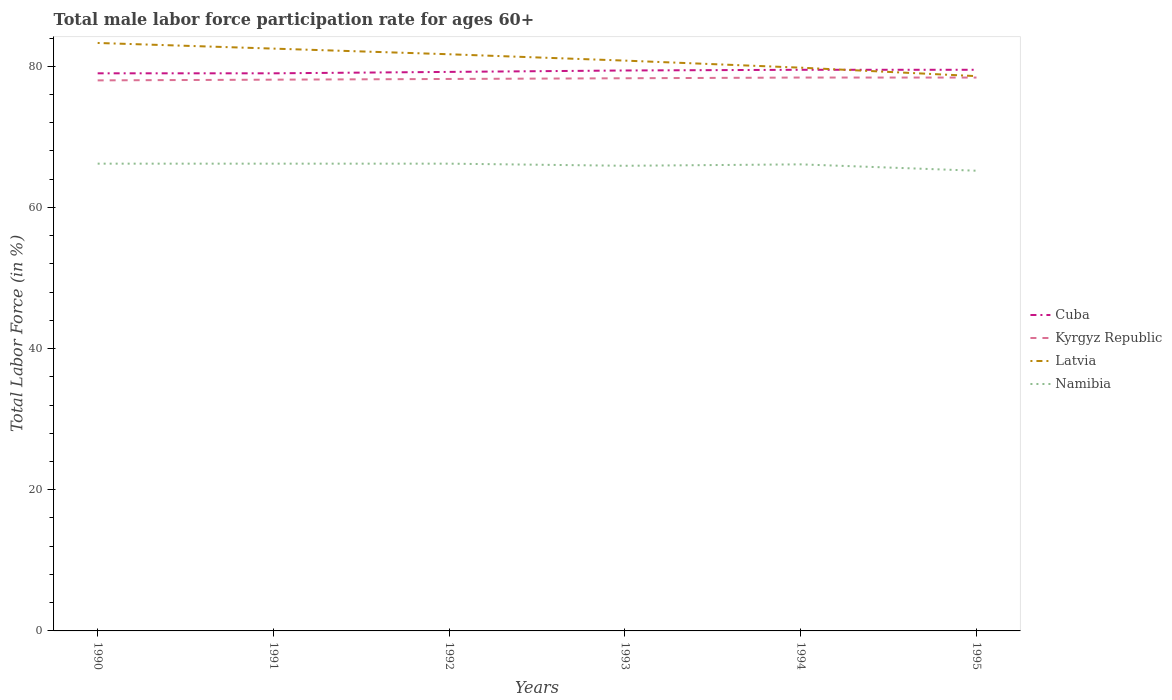How many different coloured lines are there?
Make the answer very short. 4. In which year was the male labor force participation rate in Namibia maximum?
Provide a short and direct response. 1995. What is the total male labor force participation rate in Latvia in the graph?
Your answer should be compact. 1.7. What is the difference between the highest and the second highest male labor force participation rate in Cuba?
Give a very brief answer. 0.5. Is the male labor force participation rate in Latvia strictly greater than the male labor force participation rate in Cuba over the years?
Ensure brevity in your answer.  No. How many years are there in the graph?
Ensure brevity in your answer.  6. Are the values on the major ticks of Y-axis written in scientific E-notation?
Your answer should be compact. No. Does the graph contain any zero values?
Make the answer very short. No. Does the graph contain grids?
Your response must be concise. No. How are the legend labels stacked?
Ensure brevity in your answer.  Vertical. What is the title of the graph?
Your answer should be very brief. Total male labor force participation rate for ages 60+. What is the label or title of the X-axis?
Your answer should be compact. Years. What is the label or title of the Y-axis?
Offer a terse response. Total Labor Force (in %). What is the Total Labor Force (in %) in Cuba in 1990?
Your answer should be very brief. 79. What is the Total Labor Force (in %) in Latvia in 1990?
Keep it short and to the point. 83.3. What is the Total Labor Force (in %) of Namibia in 1990?
Ensure brevity in your answer.  66.2. What is the Total Labor Force (in %) in Cuba in 1991?
Make the answer very short. 79. What is the Total Labor Force (in %) in Kyrgyz Republic in 1991?
Make the answer very short. 78.1. What is the Total Labor Force (in %) of Latvia in 1991?
Provide a short and direct response. 82.5. What is the Total Labor Force (in %) in Namibia in 1991?
Offer a very short reply. 66.2. What is the Total Labor Force (in %) in Cuba in 1992?
Your response must be concise. 79.2. What is the Total Labor Force (in %) in Kyrgyz Republic in 1992?
Your response must be concise. 78.2. What is the Total Labor Force (in %) in Latvia in 1992?
Keep it short and to the point. 81.7. What is the Total Labor Force (in %) in Namibia in 1992?
Make the answer very short. 66.2. What is the Total Labor Force (in %) in Cuba in 1993?
Your response must be concise. 79.4. What is the Total Labor Force (in %) of Kyrgyz Republic in 1993?
Your answer should be compact. 78.3. What is the Total Labor Force (in %) of Latvia in 1993?
Your answer should be compact. 80.8. What is the Total Labor Force (in %) in Namibia in 1993?
Offer a terse response. 65.9. What is the Total Labor Force (in %) in Cuba in 1994?
Offer a terse response. 79.5. What is the Total Labor Force (in %) in Kyrgyz Republic in 1994?
Your answer should be very brief. 78.4. What is the Total Labor Force (in %) in Latvia in 1994?
Make the answer very short. 79.8. What is the Total Labor Force (in %) in Namibia in 1994?
Your answer should be compact. 66.1. What is the Total Labor Force (in %) of Cuba in 1995?
Ensure brevity in your answer.  79.5. What is the Total Labor Force (in %) in Kyrgyz Republic in 1995?
Keep it short and to the point. 78.4. What is the Total Labor Force (in %) of Latvia in 1995?
Provide a succinct answer. 78.6. What is the Total Labor Force (in %) of Namibia in 1995?
Give a very brief answer. 65.2. Across all years, what is the maximum Total Labor Force (in %) of Cuba?
Provide a short and direct response. 79.5. Across all years, what is the maximum Total Labor Force (in %) of Kyrgyz Republic?
Offer a very short reply. 78.4. Across all years, what is the maximum Total Labor Force (in %) in Latvia?
Your answer should be compact. 83.3. Across all years, what is the maximum Total Labor Force (in %) of Namibia?
Keep it short and to the point. 66.2. Across all years, what is the minimum Total Labor Force (in %) of Cuba?
Offer a terse response. 79. Across all years, what is the minimum Total Labor Force (in %) of Kyrgyz Republic?
Keep it short and to the point. 78. Across all years, what is the minimum Total Labor Force (in %) of Latvia?
Your response must be concise. 78.6. Across all years, what is the minimum Total Labor Force (in %) in Namibia?
Your answer should be very brief. 65.2. What is the total Total Labor Force (in %) in Cuba in the graph?
Give a very brief answer. 475.6. What is the total Total Labor Force (in %) of Kyrgyz Republic in the graph?
Make the answer very short. 469.4. What is the total Total Labor Force (in %) in Latvia in the graph?
Make the answer very short. 486.7. What is the total Total Labor Force (in %) in Namibia in the graph?
Provide a short and direct response. 395.8. What is the difference between the Total Labor Force (in %) of Cuba in 1990 and that in 1991?
Your answer should be very brief. 0. What is the difference between the Total Labor Force (in %) of Kyrgyz Republic in 1990 and that in 1991?
Make the answer very short. -0.1. What is the difference between the Total Labor Force (in %) of Latvia in 1990 and that in 1991?
Your answer should be very brief. 0.8. What is the difference between the Total Labor Force (in %) of Namibia in 1990 and that in 1991?
Your answer should be compact. 0. What is the difference between the Total Labor Force (in %) of Cuba in 1990 and that in 1992?
Your answer should be very brief. -0.2. What is the difference between the Total Labor Force (in %) of Latvia in 1990 and that in 1992?
Give a very brief answer. 1.6. What is the difference between the Total Labor Force (in %) in Cuba in 1990 and that in 1993?
Your answer should be compact. -0.4. What is the difference between the Total Labor Force (in %) in Kyrgyz Republic in 1990 and that in 1993?
Your response must be concise. -0.3. What is the difference between the Total Labor Force (in %) of Latvia in 1990 and that in 1993?
Make the answer very short. 2.5. What is the difference between the Total Labor Force (in %) in Namibia in 1990 and that in 1993?
Your answer should be compact. 0.3. What is the difference between the Total Labor Force (in %) of Cuba in 1990 and that in 1994?
Provide a short and direct response. -0.5. What is the difference between the Total Labor Force (in %) in Kyrgyz Republic in 1990 and that in 1994?
Your answer should be very brief. -0.4. What is the difference between the Total Labor Force (in %) in Namibia in 1990 and that in 1994?
Ensure brevity in your answer.  0.1. What is the difference between the Total Labor Force (in %) of Cuba in 1990 and that in 1995?
Offer a very short reply. -0.5. What is the difference between the Total Labor Force (in %) in Latvia in 1990 and that in 1995?
Provide a short and direct response. 4.7. What is the difference between the Total Labor Force (in %) in Namibia in 1990 and that in 1995?
Give a very brief answer. 1. What is the difference between the Total Labor Force (in %) in Cuba in 1991 and that in 1992?
Provide a succinct answer. -0.2. What is the difference between the Total Labor Force (in %) in Namibia in 1991 and that in 1992?
Your answer should be very brief. 0. What is the difference between the Total Labor Force (in %) of Cuba in 1991 and that in 1993?
Keep it short and to the point. -0.4. What is the difference between the Total Labor Force (in %) of Cuba in 1991 and that in 1994?
Make the answer very short. -0.5. What is the difference between the Total Labor Force (in %) of Latvia in 1991 and that in 1995?
Keep it short and to the point. 3.9. What is the difference between the Total Labor Force (in %) in Namibia in 1991 and that in 1995?
Offer a terse response. 1. What is the difference between the Total Labor Force (in %) in Cuba in 1992 and that in 1993?
Give a very brief answer. -0.2. What is the difference between the Total Labor Force (in %) of Kyrgyz Republic in 1992 and that in 1993?
Ensure brevity in your answer.  -0.1. What is the difference between the Total Labor Force (in %) in Latvia in 1992 and that in 1994?
Keep it short and to the point. 1.9. What is the difference between the Total Labor Force (in %) of Latvia in 1992 and that in 1995?
Offer a terse response. 3.1. What is the difference between the Total Labor Force (in %) in Cuba in 1993 and that in 1994?
Ensure brevity in your answer.  -0.1. What is the difference between the Total Labor Force (in %) in Kyrgyz Republic in 1993 and that in 1994?
Give a very brief answer. -0.1. What is the difference between the Total Labor Force (in %) of Cuba in 1993 and that in 1995?
Keep it short and to the point. -0.1. What is the difference between the Total Labor Force (in %) of Kyrgyz Republic in 1993 and that in 1995?
Provide a succinct answer. -0.1. What is the difference between the Total Labor Force (in %) of Namibia in 1993 and that in 1995?
Make the answer very short. 0.7. What is the difference between the Total Labor Force (in %) of Latvia in 1994 and that in 1995?
Make the answer very short. 1.2. What is the difference between the Total Labor Force (in %) in Cuba in 1990 and the Total Labor Force (in %) in Kyrgyz Republic in 1991?
Make the answer very short. 0.9. What is the difference between the Total Labor Force (in %) in Kyrgyz Republic in 1990 and the Total Labor Force (in %) in Latvia in 1991?
Provide a succinct answer. -4.5. What is the difference between the Total Labor Force (in %) in Kyrgyz Republic in 1990 and the Total Labor Force (in %) in Namibia in 1992?
Your answer should be compact. 11.8. What is the difference between the Total Labor Force (in %) in Cuba in 1990 and the Total Labor Force (in %) in Kyrgyz Republic in 1993?
Your response must be concise. 0.7. What is the difference between the Total Labor Force (in %) of Cuba in 1990 and the Total Labor Force (in %) of Latvia in 1993?
Your answer should be very brief. -1.8. What is the difference between the Total Labor Force (in %) of Cuba in 1990 and the Total Labor Force (in %) of Namibia in 1993?
Provide a short and direct response. 13.1. What is the difference between the Total Labor Force (in %) of Kyrgyz Republic in 1990 and the Total Labor Force (in %) of Latvia in 1993?
Your answer should be compact. -2.8. What is the difference between the Total Labor Force (in %) in Latvia in 1990 and the Total Labor Force (in %) in Namibia in 1993?
Ensure brevity in your answer.  17.4. What is the difference between the Total Labor Force (in %) in Cuba in 1990 and the Total Labor Force (in %) in Kyrgyz Republic in 1994?
Provide a succinct answer. 0.6. What is the difference between the Total Labor Force (in %) of Cuba in 1990 and the Total Labor Force (in %) of Latvia in 1994?
Offer a terse response. -0.8. What is the difference between the Total Labor Force (in %) in Kyrgyz Republic in 1990 and the Total Labor Force (in %) in Namibia in 1994?
Keep it short and to the point. 11.9. What is the difference between the Total Labor Force (in %) in Latvia in 1990 and the Total Labor Force (in %) in Namibia in 1994?
Offer a very short reply. 17.2. What is the difference between the Total Labor Force (in %) in Kyrgyz Republic in 1990 and the Total Labor Force (in %) in Namibia in 1995?
Keep it short and to the point. 12.8. What is the difference between the Total Labor Force (in %) in Cuba in 1991 and the Total Labor Force (in %) in Latvia in 1992?
Your answer should be compact. -2.7. What is the difference between the Total Labor Force (in %) of Kyrgyz Republic in 1991 and the Total Labor Force (in %) of Latvia in 1992?
Make the answer very short. -3.6. What is the difference between the Total Labor Force (in %) in Kyrgyz Republic in 1991 and the Total Labor Force (in %) in Namibia in 1992?
Your answer should be very brief. 11.9. What is the difference between the Total Labor Force (in %) in Latvia in 1991 and the Total Labor Force (in %) in Namibia in 1992?
Ensure brevity in your answer.  16.3. What is the difference between the Total Labor Force (in %) of Cuba in 1991 and the Total Labor Force (in %) of Namibia in 1993?
Offer a very short reply. 13.1. What is the difference between the Total Labor Force (in %) in Kyrgyz Republic in 1991 and the Total Labor Force (in %) in Latvia in 1993?
Your answer should be very brief. -2.7. What is the difference between the Total Labor Force (in %) of Latvia in 1991 and the Total Labor Force (in %) of Namibia in 1993?
Your response must be concise. 16.6. What is the difference between the Total Labor Force (in %) in Cuba in 1991 and the Total Labor Force (in %) in Latvia in 1994?
Provide a short and direct response. -0.8. What is the difference between the Total Labor Force (in %) in Kyrgyz Republic in 1991 and the Total Labor Force (in %) in Namibia in 1994?
Give a very brief answer. 12. What is the difference between the Total Labor Force (in %) in Cuba in 1991 and the Total Labor Force (in %) in Latvia in 1995?
Keep it short and to the point. 0.4. What is the difference between the Total Labor Force (in %) of Kyrgyz Republic in 1991 and the Total Labor Force (in %) of Latvia in 1995?
Your response must be concise. -0.5. What is the difference between the Total Labor Force (in %) in Kyrgyz Republic in 1991 and the Total Labor Force (in %) in Namibia in 1995?
Offer a terse response. 12.9. What is the difference between the Total Labor Force (in %) of Cuba in 1992 and the Total Labor Force (in %) of Kyrgyz Republic in 1993?
Offer a very short reply. 0.9. What is the difference between the Total Labor Force (in %) of Kyrgyz Republic in 1992 and the Total Labor Force (in %) of Latvia in 1993?
Your response must be concise. -2.6. What is the difference between the Total Labor Force (in %) in Cuba in 1992 and the Total Labor Force (in %) in Kyrgyz Republic in 1994?
Ensure brevity in your answer.  0.8. What is the difference between the Total Labor Force (in %) in Cuba in 1992 and the Total Labor Force (in %) in Latvia in 1994?
Offer a very short reply. -0.6. What is the difference between the Total Labor Force (in %) in Cuba in 1992 and the Total Labor Force (in %) in Namibia in 1994?
Provide a short and direct response. 13.1. What is the difference between the Total Labor Force (in %) in Latvia in 1992 and the Total Labor Force (in %) in Namibia in 1994?
Offer a very short reply. 15.6. What is the difference between the Total Labor Force (in %) of Kyrgyz Republic in 1992 and the Total Labor Force (in %) of Namibia in 1995?
Offer a terse response. 13. What is the difference between the Total Labor Force (in %) of Cuba in 1993 and the Total Labor Force (in %) of Latvia in 1994?
Offer a terse response. -0.4. What is the difference between the Total Labor Force (in %) in Cuba in 1993 and the Total Labor Force (in %) in Namibia in 1994?
Your answer should be compact. 13.3. What is the difference between the Total Labor Force (in %) in Kyrgyz Republic in 1993 and the Total Labor Force (in %) in Namibia in 1994?
Your response must be concise. 12.2. What is the difference between the Total Labor Force (in %) in Latvia in 1993 and the Total Labor Force (in %) in Namibia in 1994?
Your answer should be compact. 14.7. What is the difference between the Total Labor Force (in %) in Cuba in 1993 and the Total Labor Force (in %) in Kyrgyz Republic in 1995?
Provide a short and direct response. 1. What is the difference between the Total Labor Force (in %) in Cuba in 1994 and the Total Labor Force (in %) in Namibia in 1995?
Your answer should be compact. 14.3. What is the difference between the Total Labor Force (in %) of Kyrgyz Republic in 1994 and the Total Labor Force (in %) of Latvia in 1995?
Ensure brevity in your answer.  -0.2. What is the difference between the Total Labor Force (in %) of Latvia in 1994 and the Total Labor Force (in %) of Namibia in 1995?
Make the answer very short. 14.6. What is the average Total Labor Force (in %) in Cuba per year?
Ensure brevity in your answer.  79.27. What is the average Total Labor Force (in %) of Kyrgyz Republic per year?
Your answer should be very brief. 78.23. What is the average Total Labor Force (in %) in Latvia per year?
Offer a very short reply. 81.12. What is the average Total Labor Force (in %) in Namibia per year?
Offer a very short reply. 65.97. In the year 1990, what is the difference between the Total Labor Force (in %) of Cuba and Total Labor Force (in %) of Latvia?
Give a very brief answer. -4.3. In the year 1990, what is the difference between the Total Labor Force (in %) of Kyrgyz Republic and Total Labor Force (in %) of Latvia?
Your answer should be compact. -5.3. In the year 1990, what is the difference between the Total Labor Force (in %) in Latvia and Total Labor Force (in %) in Namibia?
Keep it short and to the point. 17.1. In the year 1991, what is the difference between the Total Labor Force (in %) in Cuba and Total Labor Force (in %) in Latvia?
Make the answer very short. -3.5. In the year 1991, what is the difference between the Total Labor Force (in %) of Kyrgyz Republic and Total Labor Force (in %) of Namibia?
Your response must be concise. 11.9. In the year 1992, what is the difference between the Total Labor Force (in %) of Cuba and Total Labor Force (in %) of Kyrgyz Republic?
Offer a terse response. 1. In the year 1992, what is the difference between the Total Labor Force (in %) in Cuba and Total Labor Force (in %) in Latvia?
Ensure brevity in your answer.  -2.5. In the year 1992, what is the difference between the Total Labor Force (in %) of Cuba and Total Labor Force (in %) of Namibia?
Offer a very short reply. 13. In the year 1992, what is the difference between the Total Labor Force (in %) in Latvia and Total Labor Force (in %) in Namibia?
Offer a very short reply. 15.5. In the year 1993, what is the difference between the Total Labor Force (in %) of Cuba and Total Labor Force (in %) of Kyrgyz Republic?
Keep it short and to the point. 1.1. In the year 1993, what is the difference between the Total Labor Force (in %) of Cuba and Total Labor Force (in %) of Latvia?
Your answer should be compact. -1.4. In the year 1993, what is the difference between the Total Labor Force (in %) in Latvia and Total Labor Force (in %) in Namibia?
Ensure brevity in your answer.  14.9. In the year 1994, what is the difference between the Total Labor Force (in %) of Cuba and Total Labor Force (in %) of Kyrgyz Republic?
Keep it short and to the point. 1.1. In the year 1994, what is the difference between the Total Labor Force (in %) of Cuba and Total Labor Force (in %) of Namibia?
Ensure brevity in your answer.  13.4. In the year 1994, what is the difference between the Total Labor Force (in %) in Kyrgyz Republic and Total Labor Force (in %) in Latvia?
Give a very brief answer. -1.4. In the year 1994, what is the difference between the Total Labor Force (in %) of Kyrgyz Republic and Total Labor Force (in %) of Namibia?
Offer a terse response. 12.3. In the year 1995, what is the difference between the Total Labor Force (in %) in Kyrgyz Republic and Total Labor Force (in %) in Namibia?
Provide a short and direct response. 13.2. In the year 1995, what is the difference between the Total Labor Force (in %) in Latvia and Total Labor Force (in %) in Namibia?
Ensure brevity in your answer.  13.4. What is the ratio of the Total Labor Force (in %) of Cuba in 1990 to that in 1991?
Provide a succinct answer. 1. What is the ratio of the Total Labor Force (in %) of Kyrgyz Republic in 1990 to that in 1991?
Keep it short and to the point. 1. What is the ratio of the Total Labor Force (in %) in Latvia in 1990 to that in 1991?
Your response must be concise. 1.01. What is the ratio of the Total Labor Force (in %) in Namibia in 1990 to that in 1991?
Your answer should be very brief. 1. What is the ratio of the Total Labor Force (in %) of Cuba in 1990 to that in 1992?
Provide a succinct answer. 1. What is the ratio of the Total Labor Force (in %) in Latvia in 1990 to that in 1992?
Make the answer very short. 1.02. What is the ratio of the Total Labor Force (in %) of Cuba in 1990 to that in 1993?
Give a very brief answer. 0.99. What is the ratio of the Total Labor Force (in %) in Latvia in 1990 to that in 1993?
Your answer should be very brief. 1.03. What is the ratio of the Total Labor Force (in %) in Cuba in 1990 to that in 1994?
Your response must be concise. 0.99. What is the ratio of the Total Labor Force (in %) in Kyrgyz Republic in 1990 to that in 1994?
Offer a very short reply. 0.99. What is the ratio of the Total Labor Force (in %) in Latvia in 1990 to that in 1994?
Offer a terse response. 1.04. What is the ratio of the Total Labor Force (in %) in Kyrgyz Republic in 1990 to that in 1995?
Offer a very short reply. 0.99. What is the ratio of the Total Labor Force (in %) in Latvia in 1990 to that in 1995?
Provide a short and direct response. 1.06. What is the ratio of the Total Labor Force (in %) of Namibia in 1990 to that in 1995?
Your answer should be compact. 1.02. What is the ratio of the Total Labor Force (in %) in Kyrgyz Republic in 1991 to that in 1992?
Your response must be concise. 1. What is the ratio of the Total Labor Force (in %) in Latvia in 1991 to that in 1992?
Make the answer very short. 1.01. What is the ratio of the Total Labor Force (in %) in Namibia in 1991 to that in 1992?
Your answer should be very brief. 1. What is the ratio of the Total Labor Force (in %) in Cuba in 1991 to that in 1993?
Keep it short and to the point. 0.99. What is the ratio of the Total Labor Force (in %) in Kyrgyz Republic in 1991 to that in 1993?
Your answer should be compact. 1. What is the ratio of the Total Labor Force (in %) in Latvia in 1991 to that in 1993?
Offer a terse response. 1.02. What is the ratio of the Total Labor Force (in %) in Namibia in 1991 to that in 1993?
Your answer should be compact. 1. What is the ratio of the Total Labor Force (in %) in Kyrgyz Republic in 1991 to that in 1994?
Your answer should be compact. 1. What is the ratio of the Total Labor Force (in %) of Latvia in 1991 to that in 1994?
Provide a short and direct response. 1.03. What is the ratio of the Total Labor Force (in %) in Namibia in 1991 to that in 1994?
Offer a very short reply. 1. What is the ratio of the Total Labor Force (in %) of Kyrgyz Republic in 1991 to that in 1995?
Make the answer very short. 1. What is the ratio of the Total Labor Force (in %) in Latvia in 1991 to that in 1995?
Your answer should be compact. 1.05. What is the ratio of the Total Labor Force (in %) in Namibia in 1991 to that in 1995?
Provide a short and direct response. 1.02. What is the ratio of the Total Labor Force (in %) of Kyrgyz Republic in 1992 to that in 1993?
Ensure brevity in your answer.  1. What is the ratio of the Total Labor Force (in %) in Latvia in 1992 to that in 1993?
Provide a succinct answer. 1.01. What is the ratio of the Total Labor Force (in %) of Namibia in 1992 to that in 1993?
Ensure brevity in your answer.  1. What is the ratio of the Total Labor Force (in %) in Kyrgyz Republic in 1992 to that in 1994?
Provide a short and direct response. 1. What is the ratio of the Total Labor Force (in %) of Latvia in 1992 to that in 1994?
Your answer should be very brief. 1.02. What is the ratio of the Total Labor Force (in %) in Cuba in 1992 to that in 1995?
Provide a short and direct response. 1. What is the ratio of the Total Labor Force (in %) of Kyrgyz Republic in 1992 to that in 1995?
Offer a very short reply. 1. What is the ratio of the Total Labor Force (in %) of Latvia in 1992 to that in 1995?
Make the answer very short. 1.04. What is the ratio of the Total Labor Force (in %) of Namibia in 1992 to that in 1995?
Your response must be concise. 1.02. What is the ratio of the Total Labor Force (in %) in Latvia in 1993 to that in 1994?
Offer a terse response. 1.01. What is the ratio of the Total Labor Force (in %) in Cuba in 1993 to that in 1995?
Your answer should be compact. 1. What is the ratio of the Total Labor Force (in %) of Latvia in 1993 to that in 1995?
Offer a terse response. 1.03. What is the ratio of the Total Labor Force (in %) of Namibia in 1993 to that in 1995?
Your response must be concise. 1.01. What is the ratio of the Total Labor Force (in %) of Latvia in 1994 to that in 1995?
Offer a terse response. 1.02. What is the ratio of the Total Labor Force (in %) of Namibia in 1994 to that in 1995?
Offer a terse response. 1.01. What is the difference between the highest and the second highest Total Labor Force (in %) in Cuba?
Your response must be concise. 0. What is the difference between the highest and the second highest Total Labor Force (in %) of Latvia?
Provide a short and direct response. 0.8. What is the difference between the highest and the lowest Total Labor Force (in %) in Kyrgyz Republic?
Provide a succinct answer. 0.4. What is the difference between the highest and the lowest Total Labor Force (in %) of Namibia?
Offer a very short reply. 1. 